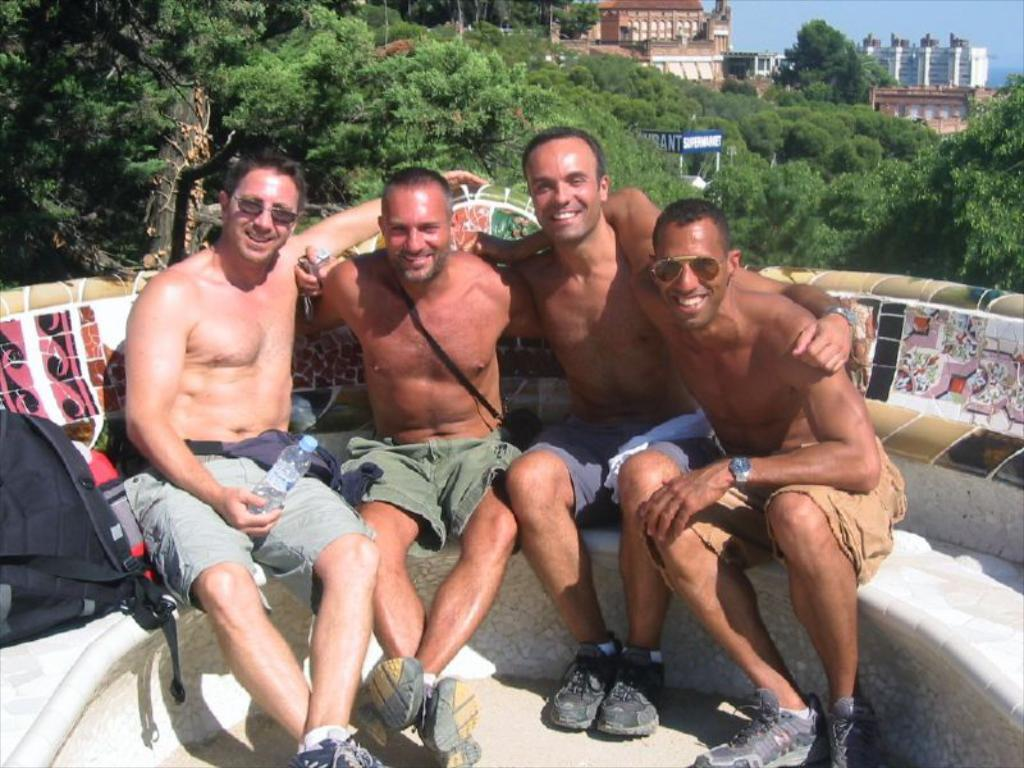What are the people in the image doing? The people in the image are sitting. What is one person holding in the image? One person is holding a bottle. What else can be seen in the image besides the people? There are bags visible in the image. What can be seen in the background of the image? There are trees and buildings in the background of the image. What is the color of the sky in the image? The sky is blue in color. What attraction can be seen in the image? There is no specific attraction mentioned or visible in the image. 